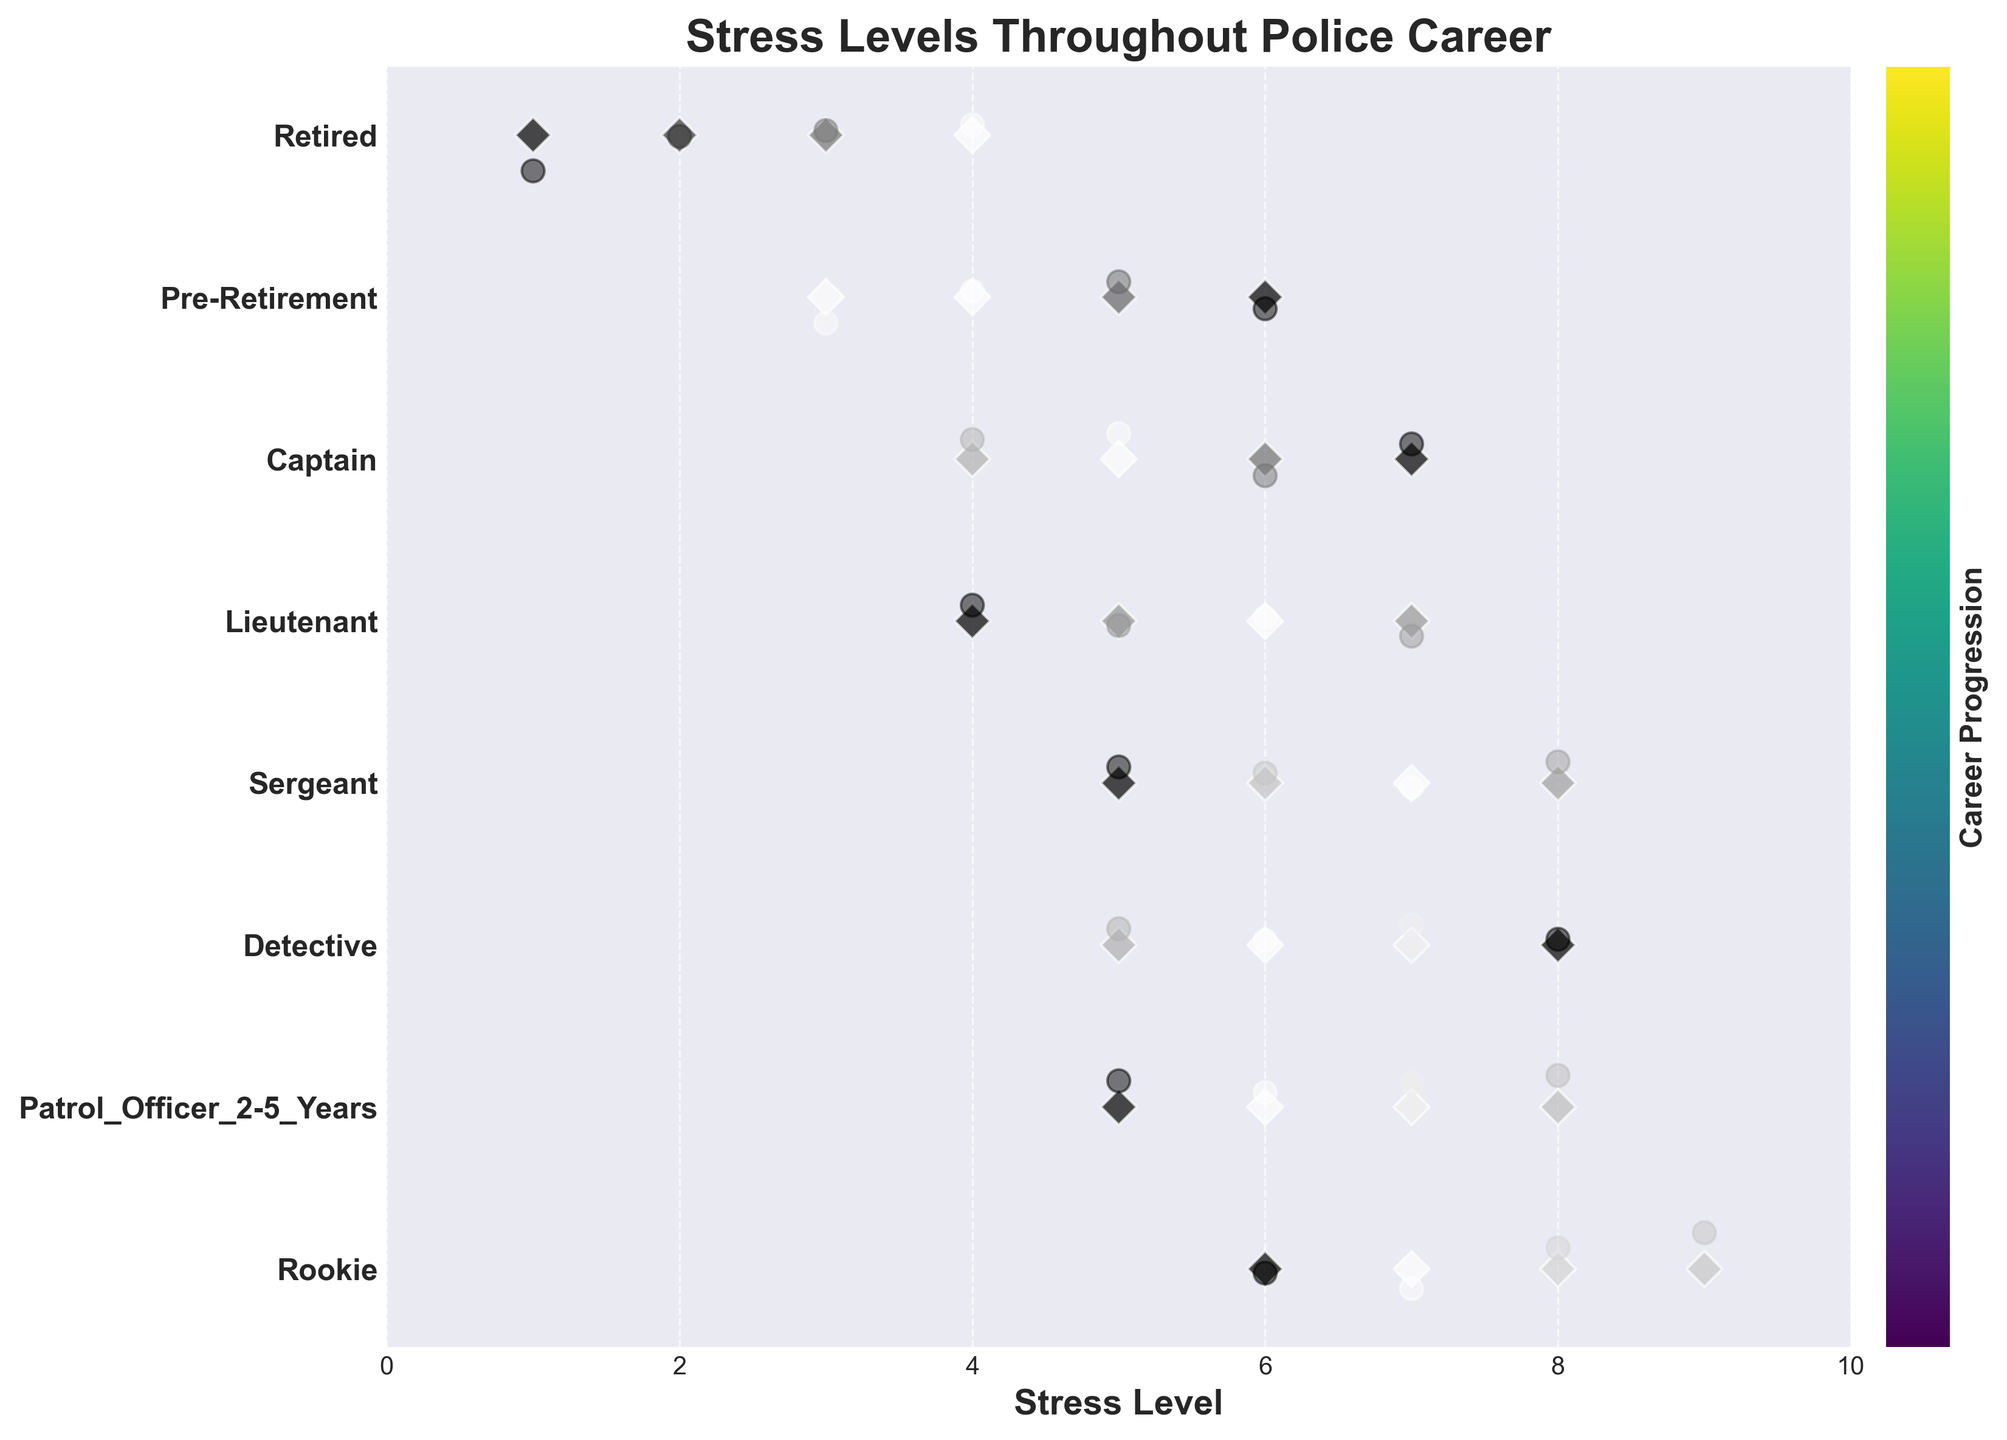Which phase has the lowest median stress level? To determine the phase with the lowest median stress level, we observe all the data points for each career phase and arrange them. The median for 'Pre-Retirement' is 4.5 (middle value between 4 and 5), and for 'Retired' is 3 (middle value between 3 and 4). Thus, 'Retired' has the lowest median.
Answer: Retired What is the highest stress level recorded in the phase 'Rookie'? Look at the data points in the 'Rookie' phase to find the maximum value. The stress levels are 6, 7, 8, and 9. The highest value present is 9.
Answer: 9 Which career phase shows a consistently higher range of stress levels? Compare the range (difference between maximum and minimum values) of stress levels for each phase. 'Rookie' has a range from 6 to 9, 'Patrol_Officer_2-5_Years' from 5 to 8, 'Detective' from 5 to 8, etc. 'Rookie' and 'Patrol_Officer_2-5_Years' tied for the highest range, both with a range of 4. But, 'Rookie' shows tighter clustering at the high end.
Answer: Rookie How do the stress levels of 'Retired' officers compare with those of 'Sergeant'? Analyze the stress values for 'Retired' (1, 2, 3, 4) and 'Sergeant' (5, 6, 7, 8). Notice that 'Retired' officers report consistently lower stress levels compared to 'Sergeant' officers.
Answer: Retired have lower stress What is the average stress level for 'Lieutenant'? List the stress levels for 'Lieutenant' as 4, 5, 6, 7. Sum these values to get 22, then divide by the number of data points, which is 4. The average is 22/4 = 5.5.
Answer: 5.5 